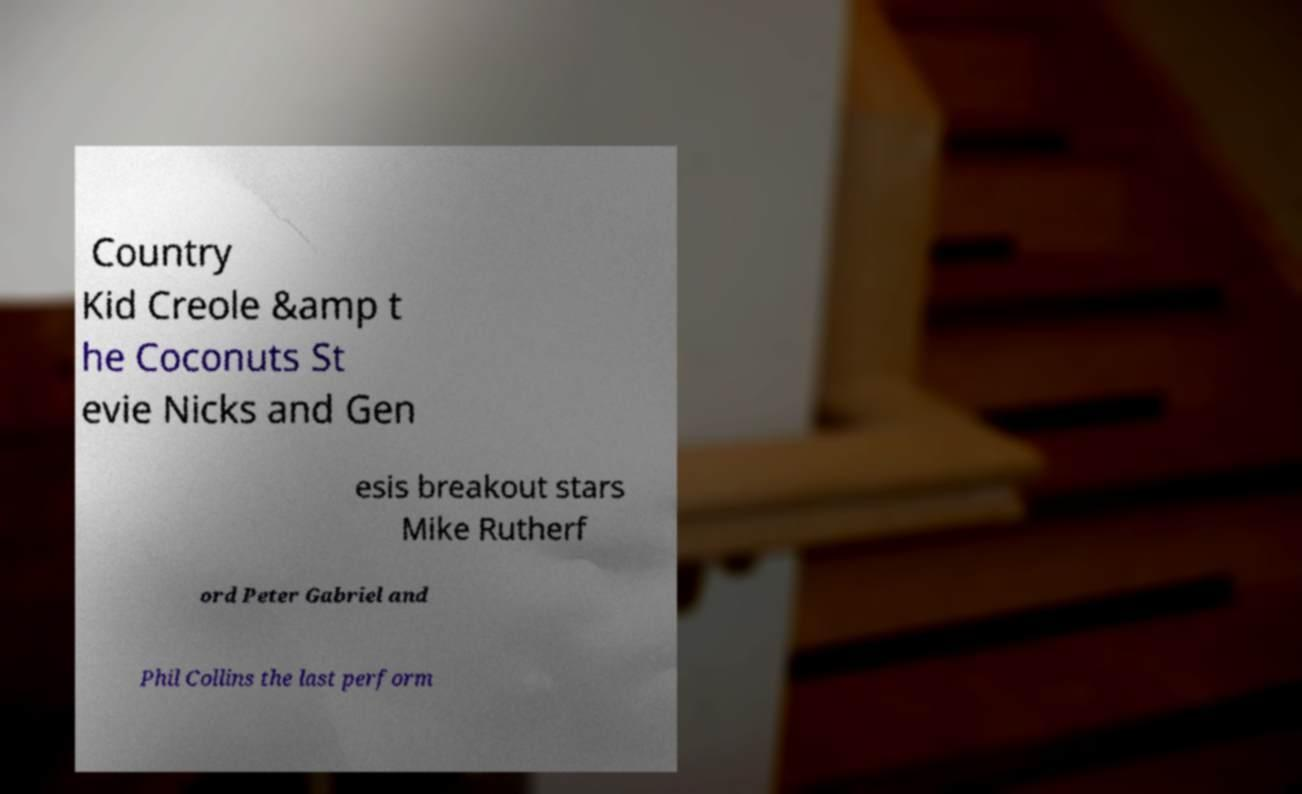Could you assist in decoding the text presented in this image and type it out clearly? Country Kid Creole &amp t he Coconuts St evie Nicks and Gen esis breakout stars Mike Rutherf ord Peter Gabriel and Phil Collins the last perform 